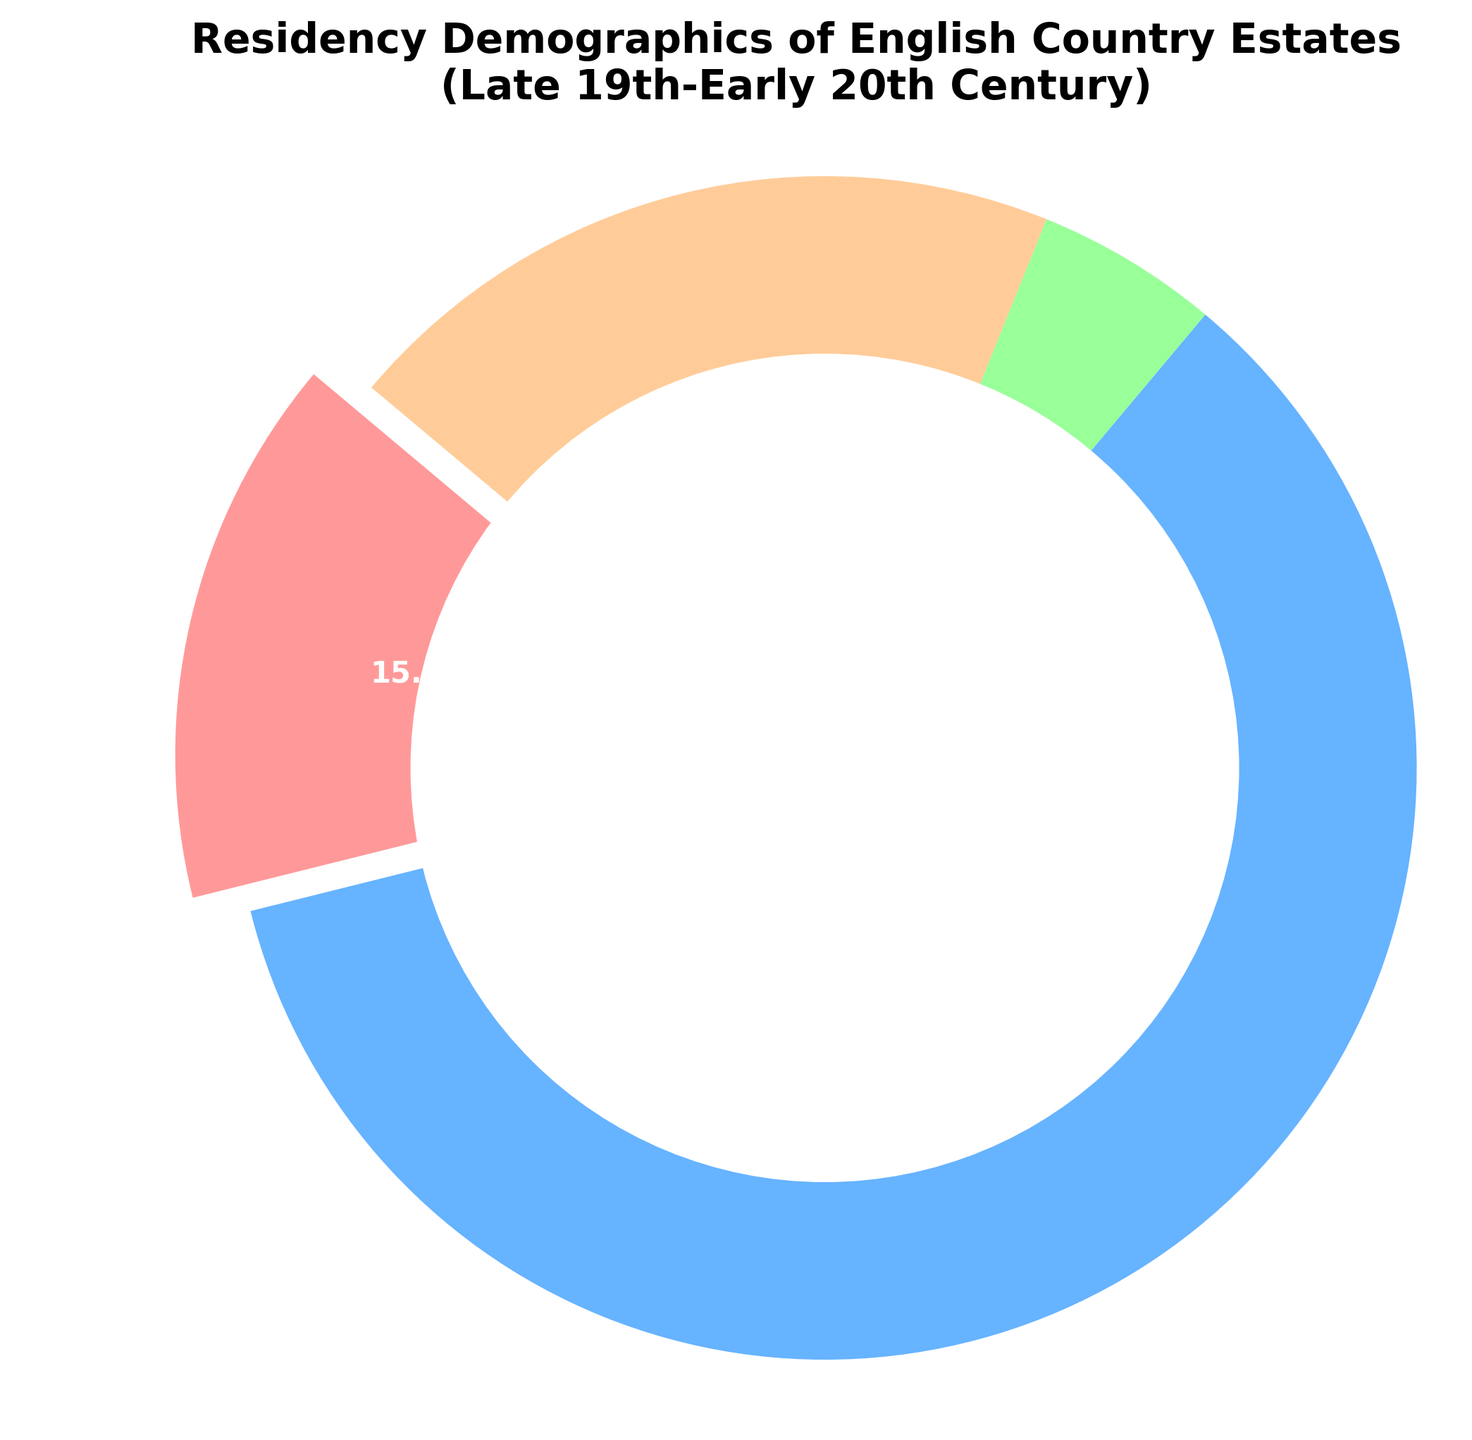Which group accounts for the largest segment of residents? To determine the largest segment, observe the pie chart and compare the size of each slice. The 'Servants' segment has the largest slice.
Answer: Servants What percentage of the residents are Nobility? Find the slice labeled 'Nobility' and refer to the percentage shown on the pie chart. It is labeled as 15%.
Answer: 15% How much larger is the Tenant segment compared to the Guest segment? Observe the percentages of both 'Tenants' and 'Guests' segments. 'Tenants' account for 20%, and 'Guests' for 5%. Subtract the smaller percentage from the larger one: 20% - 5% = 15%.
Answer: 15% Which segments are smaller than the Nobility segment? Compare the percentage of the 'Nobility' segment (15%) to the other segments. The 'Guests' segment is smaller (5%).
Answer: Guests What is the combined percentage of Nobility and Guests? Add the percentages of 'Nobility' and 'Guests' segments: 15% + 5% = 20%.
Answer: 20% What fraction of the estate residents are either Servants or Tenants? Combine the percentages of the 'Servants' and 'Tenants' segments: 60% + 20% = 80%. Since the total percentage must equal 100%, the fraction is 80/100.
Answer: 80% What's the difference in percentage between the Nobility and Servants segments? Subtract the percentage of the 'Nobility' segment (15%) from the 'Servants' segment (60%): 60% - 15% = 45%.
Answer: 45% If you combine the Nobility and Tenants segments, which group becomes larger, them or the Servants? Sum the percentages of 'Nobility' (15%) and 'Tenants' (20%); the total is 35%. Compare this to the 'Servants' (60%), and observe that the 'Servants' segment remains larger.
Answer: Servants 